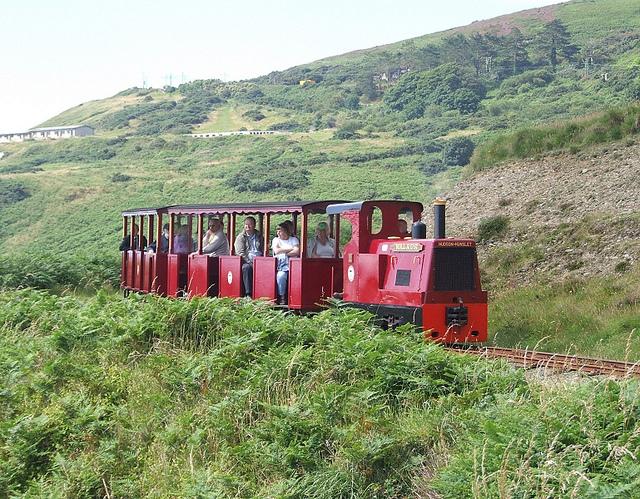How many cars are behind the train?
Quick response, please. 2. Do you see any high rise buildings?
Be succinct. No. How many cars are traveling behind the train?
Short answer required. 2. 